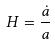Convert formula to latex. <formula><loc_0><loc_0><loc_500><loc_500>H = \frac { \dot { a } } { a }</formula> 